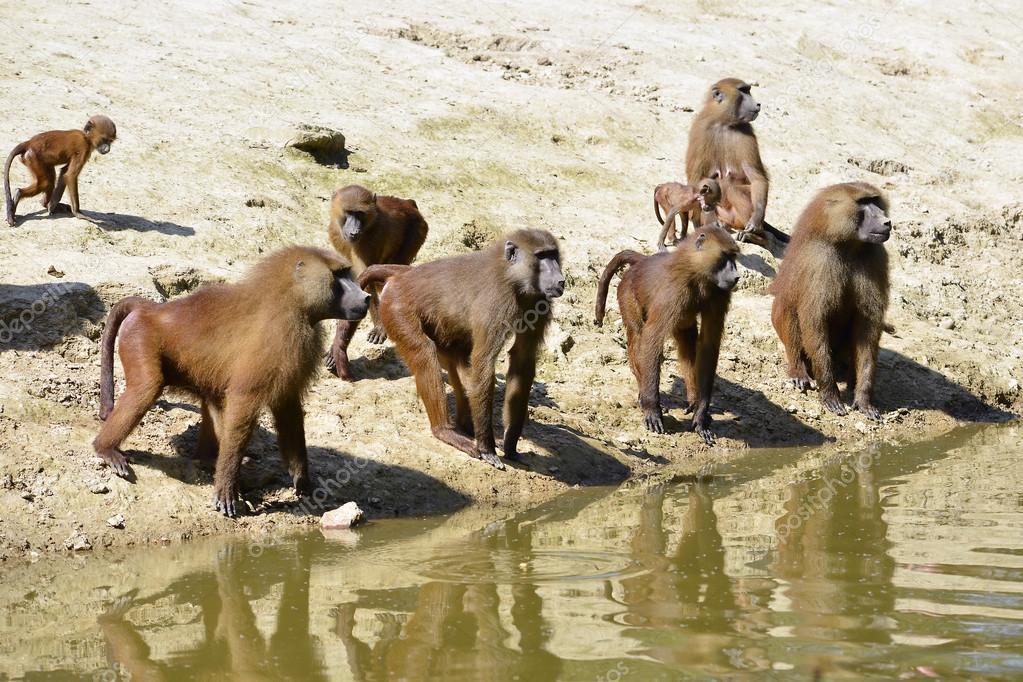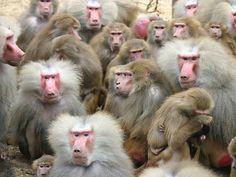The first image is the image on the left, the second image is the image on the right. Assess this claim about the two images: "Right image shows a group of baboons gathered but not closely huddled in a field with plant life present.". Correct or not? Answer yes or no. No. The first image is the image on the left, the second image is the image on the right. Analyze the images presented: Is the assertion "The animals in the image on the left are near a body of water." valid? Answer yes or no. Yes. 